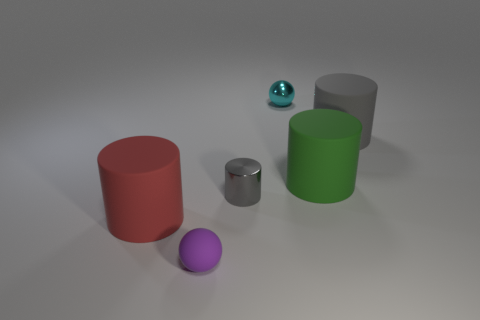Subtract all yellow balls. How many gray cylinders are left? 2 Subtract all green cylinders. How many cylinders are left? 3 Subtract 2 cylinders. How many cylinders are left? 2 Subtract all green cylinders. How many cylinders are left? 3 Add 1 big green rubber things. How many objects exist? 7 Subtract all spheres. How many objects are left? 4 Add 4 large red objects. How many large red objects exist? 5 Subtract 0 blue balls. How many objects are left? 6 Subtract all blue cylinders. Subtract all red spheres. How many cylinders are left? 4 Subtract all large green matte things. Subtract all cyan metallic balls. How many objects are left? 4 